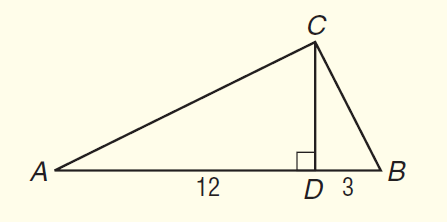Answer the mathemtical geometry problem and directly provide the correct option letter.
Question: In \triangle A B C, C D is an altitude and m \angle A C B = 90. If A D = 12 and B D = 3, find A C to the nearest tenth.
Choices: A: 6.5 B: 9.0 C: 13.4 D: 15.0 C 